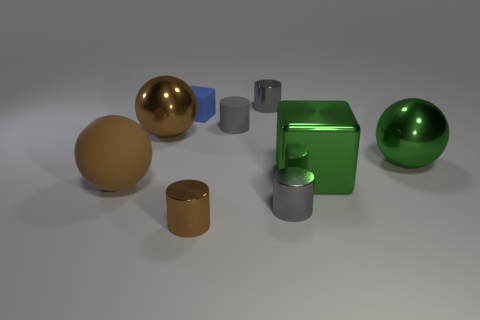Subtract all metal cylinders. How many cylinders are left? 1 Subtract all green spheres. How many spheres are left? 2 Subtract all cubes. How many objects are left? 7 Add 2 brown metal cylinders. How many brown metal cylinders are left? 3 Add 3 yellow metallic cylinders. How many yellow metallic cylinders exist? 3 Subtract 0 red cubes. How many objects are left? 9 Subtract 2 cylinders. How many cylinders are left? 2 Subtract all gray balls. Subtract all yellow cubes. How many balls are left? 3 Subtract all blue spheres. How many purple cylinders are left? 0 Subtract all green shiny cylinders. Subtract all small brown cylinders. How many objects are left? 8 